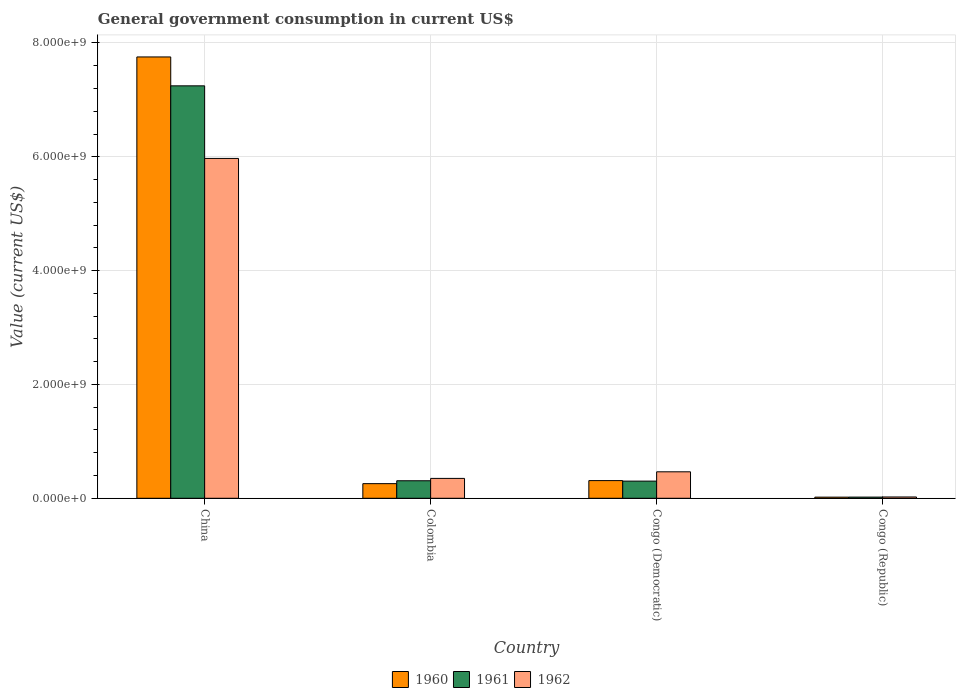How many bars are there on the 3rd tick from the left?
Provide a succinct answer. 3. How many bars are there on the 2nd tick from the right?
Your answer should be very brief. 3. What is the label of the 2nd group of bars from the left?
Make the answer very short. Colombia. In how many cases, is the number of bars for a given country not equal to the number of legend labels?
Provide a succinct answer. 0. What is the government conusmption in 1960 in Congo (Republic)?
Offer a terse response. 1.99e+07. Across all countries, what is the maximum government conusmption in 1960?
Keep it short and to the point. 7.75e+09. Across all countries, what is the minimum government conusmption in 1961?
Keep it short and to the point. 2.06e+07. In which country was the government conusmption in 1960 maximum?
Keep it short and to the point. China. In which country was the government conusmption in 1961 minimum?
Your response must be concise. Congo (Republic). What is the total government conusmption in 1961 in the graph?
Make the answer very short. 7.88e+09. What is the difference between the government conusmption in 1962 in Colombia and that in Congo (Democratic)?
Offer a terse response. -1.16e+08. What is the difference between the government conusmption in 1962 in Congo (Democratic) and the government conusmption in 1960 in Congo (Republic)?
Your response must be concise. 4.45e+08. What is the average government conusmption in 1960 per country?
Your response must be concise. 2.09e+09. What is the difference between the government conusmption of/in 1962 and government conusmption of/in 1961 in China?
Offer a terse response. -1.28e+09. In how many countries, is the government conusmption in 1961 greater than 2400000000 US$?
Give a very brief answer. 1. What is the ratio of the government conusmption in 1960 in Colombia to that in Congo (Republic)?
Offer a very short reply. 12.93. What is the difference between the highest and the second highest government conusmption in 1962?
Ensure brevity in your answer.  -5.62e+09. What is the difference between the highest and the lowest government conusmption in 1960?
Keep it short and to the point. 7.73e+09. What does the 2nd bar from the left in Colombia represents?
Your response must be concise. 1961. What does the 2nd bar from the right in Congo (Republic) represents?
Give a very brief answer. 1961. How many bars are there?
Offer a very short reply. 12. Are the values on the major ticks of Y-axis written in scientific E-notation?
Provide a short and direct response. Yes. Does the graph contain grids?
Your response must be concise. Yes. Where does the legend appear in the graph?
Your answer should be compact. Bottom center. What is the title of the graph?
Keep it short and to the point. General government consumption in current US$. Does "1972" appear as one of the legend labels in the graph?
Your answer should be very brief. No. What is the label or title of the Y-axis?
Provide a succinct answer. Value (current US$). What is the Value (current US$) in 1960 in China?
Your answer should be very brief. 7.75e+09. What is the Value (current US$) of 1961 in China?
Provide a succinct answer. 7.25e+09. What is the Value (current US$) of 1962 in China?
Your answer should be very brief. 5.97e+09. What is the Value (current US$) of 1960 in Colombia?
Make the answer very short. 2.57e+08. What is the Value (current US$) of 1961 in Colombia?
Provide a short and direct response. 3.08e+08. What is the Value (current US$) of 1962 in Colombia?
Ensure brevity in your answer.  3.49e+08. What is the Value (current US$) in 1960 in Congo (Democratic)?
Provide a short and direct response. 3.11e+08. What is the Value (current US$) of 1961 in Congo (Democratic)?
Your answer should be very brief. 3.02e+08. What is the Value (current US$) of 1962 in Congo (Democratic)?
Keep it short and to the point. 4.65e+08. What is the Value (current US$) in 1960 in Congo (Republic)?
Your answer should be compact. 1.99e+07. What is the Value (current US$) in 1961 in Congo (Republic)?
Ensure brevity in your answer.  2.06e+07. What is the Value (current US$) in 1962 in Congo (Republic)?
Your response must be concise. 2.29e+07. Across all countries, what is the maximum Value (current US$) in 1960?
Offer a very short reply. 7.75e+09. Across all countries, what is the maximum Value (current US$) in 1961?
Keep it short and to the point. 7.25e+09. Across all countries, what is the maximum Value (current US$) of 1962?
Offer a very short reply. 5.97e+09. Across all countries, what is the minimum Value (current US$) in 1960?
Your answer should be compact. 1.99e+07. Across all countries, what is the minimum Value (current US$) in 1961?
Your answer should be very brief. 2.06e+07. Across all countries, what is the minimum Value (current US$) in 1962?
Offer a terse response. 2.29e+07. What is the total Value (current US$) of 1960 in the graph?
Keep it short and to the point. 8.34e+09. What is the total Value (current US$) in 1961 in the graph?
Offer a terse response. 7.88e+09. What is the total Value (current US$) of 1962 in the graph?
Make the answer very short. 6.81e+09. What is the difference between the Value (current US$) in 1960 in China and that in Colombia?
Give a very brief answer. 7.50e+09. What is the difference between the Value (current US$) in 1961 in China and that in Colombia?
Offer a very short reply. 6.94e+09. What is the difference between the Value (current US$) in 1962 in China and that in Colombia?
Offer a terse response. 5.62e+09. What is the difference between the Value (current US$) of 1960 in China and that in Congo (Democratic)?
Provide a succinct answer. 7.44e+09. What is the difference between the Value (current US$) of 1961 in China and that in Congo (Democratic)?
Keep it short and to the point. 6.95e+09. What is the difference between the Value (current US$) of 1962 in China and that in Congo (Democratic)?
Make the answer very short. 5.51e+09. What is the difference between the Value (current US$) in 1960 in China and that in Congo (Republic)?
Your answer should be very brief. 7.73e+09. What is the difference between the Value (current US$) of 1961 in China and that in Congo (Republic)?
Your response must be concise. 7.23e+09. What is the difference between the Value (current US$) of 1962 in China and that in Congo (Republic)?
Keep it short and to the point. 5.95e+09. What is the difference between the Value (current US$) of 1960 in Colombia and that in Congo (Democratic)?
Your answer should be compact. -5.35e+07. What is the difference between the Value (current US$) of 1961 in Colombia and that in Congo (Democratic)?
Provide a short and direct response. 6.24e+06. What is the difference between the Value (current US$) in 1962 in Colombia and that in Congo (Democratic)?
Ensure brevity in your answer.  -1.16e+08. What is the difference between the Value (current US$) in 1960 in Colombia and that in Congo (Republic)?
Offer a terse response. 2.37e+08. What is the difference between the Value (current US$) in 1961 in Colombia and that in Congo (Republic)?
Give a very brief answer. 2.87e+08. What is the difference between the Value (current US$) in 1962 in Colombia and that in Congo (Republic)?
Provide a succinct answer. 3.26e+08. What is the difference between the Value (current US$) of 1960 in Congo (Democratic) and that in Congo (Republic)?
Provide a succinct answer. 2.91e+08. What is the difference between the Value (current US$) of 1961 in Congo (Democratic) and that in Congo (Republic)?
Keep it short and to the point. 2.81e+08. What is the difference between the Value (current US$) in 1962 in Congo (Democratic) and that in Congo (Republic)?
Make the answer very short. 4.42e+08. What is the difference between the Value (current US$) in 1960 in China and the Value (current US$) in 1961 in Colombia?
Offer a very short reply. 7.45e+09. What is the difference between the Value (current US$) in 1960 in China and the Value (current US$) in 1962 in Colombia?
Ensure brevity in your answer.  7.41e+09. What is the difference between the Value (current US$) of 1961 in China and the Value (current US$) of 1962 in Colombia?
Provide a short and direct response. 6.90e+09. What is the difference between the Value (current US$) of 1960 in China and the Value (current US$) of 1961 in Congo (Democratic)?
Keep it short and to the point. 7.45e+09. What is the difference between the Value (current US$) of 1960 in China and the Value (current US$) of 1962 in Congo (Democratic)?
Your response must be concise. 7.29e+09. What is the difference between the Value (current US$) in 1961 in China and the Value (current US$) in 1962 in Congo (Democratic)?
Your answer should be compact. 6.78e+09. What is the difference between the Value (current US$) in 1960 in China and the Value (current US$) in 1961 in Congo (Republic)?
Offer a very short reply. 7.73e+09. What is the difference between the Value (current US$) of 1960 in China and the Value (current US$) of 1962 in Congo (Republic)?
Keep it short and to the point. 7.73e+09. What is the difference between the Value (current US$) of 1961 in China and the Value (current US$) of 1962 in Congo (Republic)?
Give a very brief answer. 7.22e+09. What is the difference between the Value (current US$) of 1960 in Colombia and the Value (current US$) of 1961 in Congo (Democratic)?
Provide a succinct answer. -4.46e+07. What is the difference between the Value (current US$) in 1960 in Colombia and the Value (current US$) in 1962 in Congo (Democratic)?
Give a very brief answer. -2.08e+08. What is the difference between the Value (current US$) in 1961 in Colombia and the Value (current US$) in 1962 in Congo (Democratic)?
Provide a short and direct response. -1.57e+08. What is the difference between the Value (current US$) in 1960 in Colombia and the Value (current US$) in 1961 in Congo (Republic)?
Make the answer very short. 2.36e+08. What is the difference between the Value (current US$) in 1960 in Colombia and the Value (current US$) in 1962 in Congo (Republic)?
Provide a short and direct response. 2.34e+08. What is the difference between the Value (current US$) of 1961 in Colombia and the Value (current US$) of 1962 in Congo (Republic)?
Provide a succinct answer. 2.85e+08. What is the difference between the Value (current US$) in 1960 in Congo (Democratic) and the Value (current US$) in 1961 in Congo (Republic)?
Your answer should be very brief. 2.90e+08. What is the difference between the Value (current US$) in 1960 in Congo (Democratic) and the Value (current US$) in 1962 in Congo (Republic)?
Provide a short and direct response. 2.88e+08. What is the difference between the Value (current US$) of 1961 in Congo (Democratic) and the Value (current US$) of 1962 in Congo (Republic)?
Provide a succinct answer. 2.79e+08. What is the average Value (current US$) in 1960 per country?
Give a very brief answer. 2.09e+09. What is the average Value (current US$) in 1961 per country?
Ensure brevity in your answer.  1.97e+09. What is the average Value (current US$) of 1962 per country?
Offer a very short reply. 1.70e+09. What is the difference between the Value (current US$) of 1960 and Value (current US$) of 1961 in China?
Give a very brief answer. 5.08e+08. What is the difference between the Value (current US$) of 1960 and Value (current US$) of 1962 in China?
Provide a succinct answer. 1.78e+09. What is the difference between the Value (current US$) of 1961 and Value (current US$) of 1962 in China?
Provide a short and direct response. 1.28e+09. What is the difference between the Value (current US$) of 1960 and Value (current US$) of 1961 in Colombia?
Offer a very short reply. -5.09e+07. What is the difference between the Value (current US$) in 1960 and Value (current US$) in 1962 in Colombia?
Offer a terse response. -9.22e+07. What is the difference between the Value (current US$) in 1961 and Value (current US$) in 1962 in Colombia?
Your answer should be very brief. -4.13e+07. What is the difference between the Value (current US$) in 1960 and Value (current US$) in 1961 in Congo (Democratic)?
Make the answer very short. 8.87e+06. What is the difference between the Value (current US$) of 1960 and Value (current US$) of 1962 in Congo (Democratic)?
Your answer should be very brief. -1.55e+08. What is the difference between the Value (current US$) of 1961 and Value (current US$) of 1962 in Congo (Democratic)?
Provide a succinct answer. -1.63e+08. What is the difference between the Value (current US$) in 1960 and Value (current US$) in 1961 in Congo (Republic)?
Keep it short and to the point. -7.45e+05. What is the difference between the Value (current US$) of 1960 and Value (current US$) of 1962 in Congo (Republic)?
Offer a terse response. -3.02e+06. What is the difference between the Value (current US$) of 1961 and Value (current US$) of 1962 in Congo (Republic)?
Give a very brief answer. -2.27e+06. What is the ratio of the Value (current US$) in 1960 in China to that in Colombia?
Your answer should be compact. 30.17. What is the ratio of the Value (current US$) in 1961 in China to that in Colombia?
Provide a short and direct response. 23.54. What is the ratio of the Value (current US$) in 1962 in China to that in Colombia?
Your response must be concise. 17.1. What is the ratio of the Value (current US$) of 1960 in China to that in Congo (Democratic)?
Give a very brief answer. 24.97. What is the ratio of the Value (current US$) of 1961 in China to that in Congo (Democratic)?
Provide a short and direct response. 24.02. What is the ratio of the Value (current US$) of 1962 in China to that in Congo (Democratic)?
Your answer should be compact. 12.84. What is the ratio of the Value (current US$) in 1960 in China to that in Congo (Republic)?
Ensure brevity in your answer.  389.94. What is the ratio of the Value (current US$) in 1961 in China to that in Congo (Republic)?
Your answer should be compact. 351.25. What is the ratio of the Value (current US$) in 1962 in China to that in Congo (Republic)?
Offer a very short reply. 260.7. What is the ratio of the Value (current US$) of 1960 in Colombia to that in Congo (Democratic)?
Your answer should be compact. 0.83. What is the ratio of the Value (current US$) in 1961 in Colombia to that in Congo (Democratic)?
Keep it short and to the point. 1.02. What is the ratio of the Value (current US$) in 1962 in Colombia to that in Congo (Democratic)?
Ensure brevity in your answer.  0.75. What is the ratio of the Value (current US$) in 1960 in Colombia to that in Congo (Republic)?
Make the answer very short. 12.93. What is the ratio of the Value (current US$) of 1961 in Colombia to that in Congo (Republic)?
Provide a succinct answer. 14.92. What is the ratio of the Value (current US$) of 1962 in Colombia to that in Congo (Republic)?
Ensure brevity in your answer.  15.25. What is the ratio of the Value (current US$) of 1960 in Congo (Democratic) to that in Congo (Republic)?
Make the answer very short. 15.62. What is the ratio of the Value (current US$) of 1961 in Congo (Democratic) to that in Congo (Republic)?
Provide a short and direct response. 14.62. What is the ratio of the Value (current US$) in 1962 in Congo (Democratic) to that in Congo (Republic)?
Provide a short and direct response. 20.3. What is the difference between the highest and the second highest Value (current US$) of 1960?
Make the answer very short. 7.44e+09. What is the difference between the highest and the second highest Value (current US$) in 1961?
Provide a succinct answer. 6.94e+09. What is the difference between the highest and the second highest Value (current US$) in 1962?
Keep it short and to the point. 5.51e+09. What is the difference between the highest and the lowest Value (current US$) in 1960?
Provide a succinct answer. 7.73e+09. What is the difference between the highest and the lowest Value (current US$) of 1961?
Your answer should be compact. 7.23e+09. What is the difference between the highest and the lowest Value (current US$) of 1962?
Provide a succinct answer. 5.95e+09. 